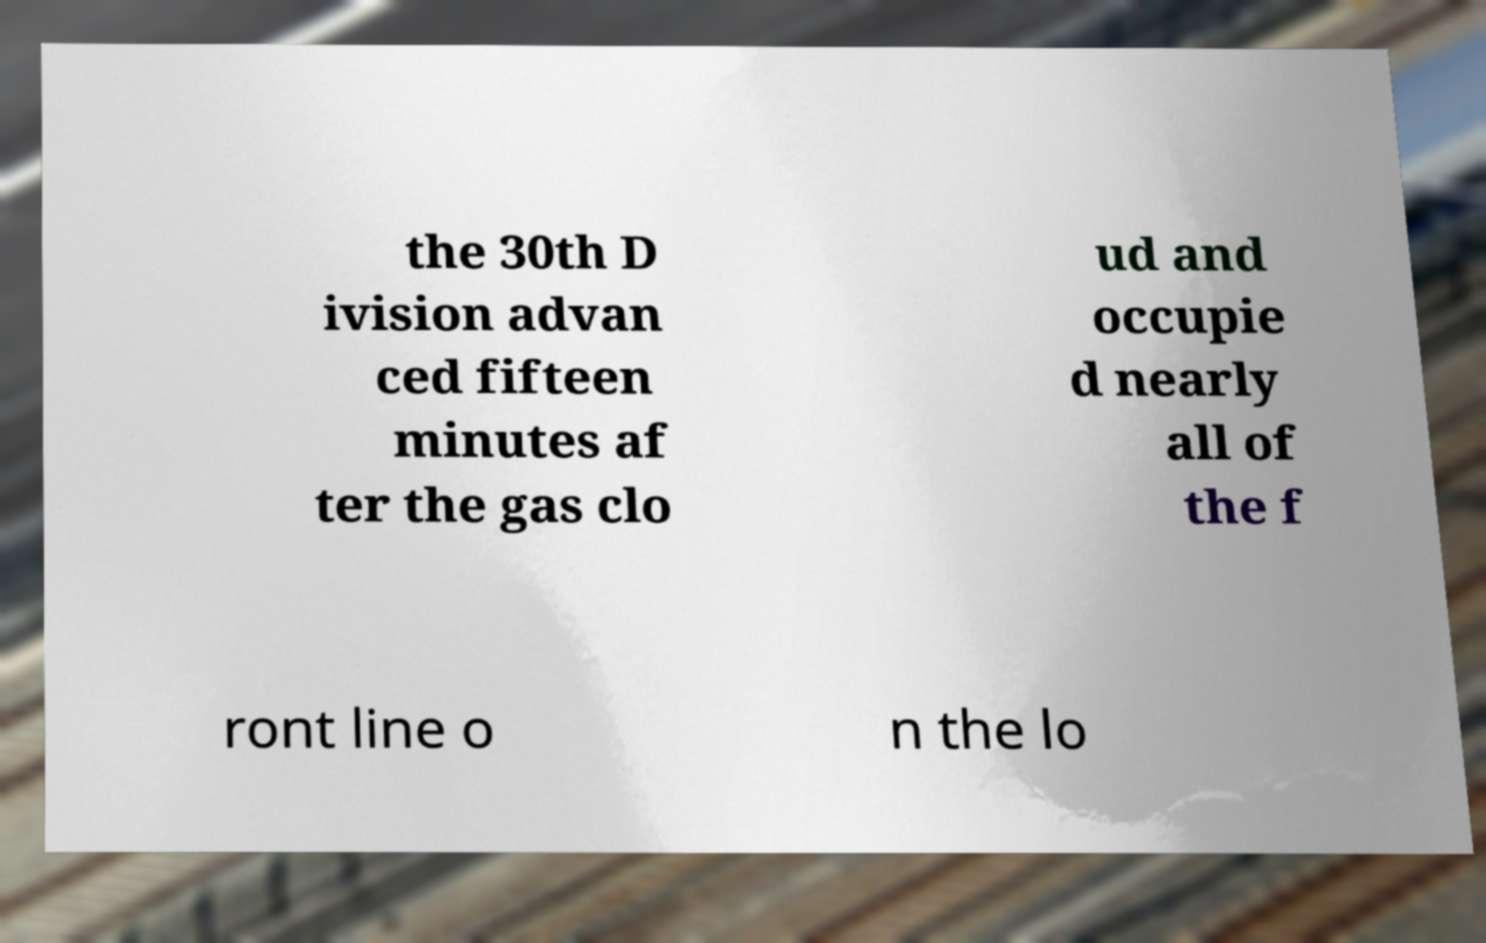Please identify and transcribe the text found in this image. the 30th D ivision advan ced fifteen minutes af ter the gas clo ud and occupie d nearly all of the f ront line o n the lo 